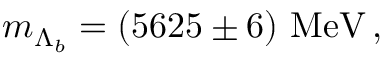<formula> <loc_0><loc_0><loc_500><loc_500>m _ { \Lambda _ { b } } = ( 5 6 2 5 \pm 6 ) M e V \, ,</formula> 